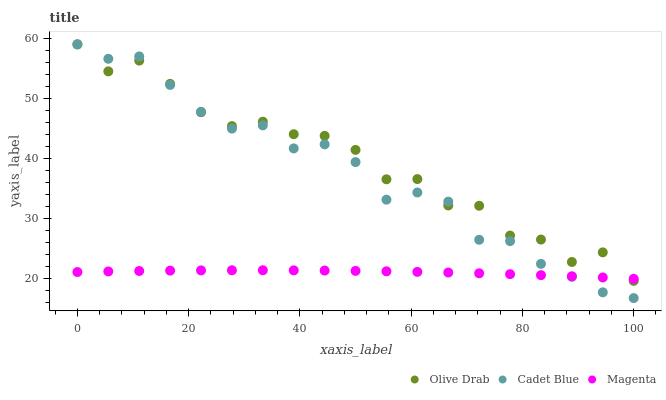Does Magenta have the minimum area under the curve?
Answer yes or no. Yes. Does Olive Drab have the maximum area under the curve?
Answer yes or no. Yes. Does Cadet Blue have the minimum area under the curve?
Answer yes or no. No. Does Cadet Blue have the maximum area under the curve?
Answer yes or no. No. Is Magenta the smoothest?
Answer yes or no. Yes. Is Olive Drab the roughest?
Answer yes or no. Yes. Is Cadet Blue the smoothest?
Answer yes or no. No. Is Cadet Blue the roughest?
Answer yes or no. No. Does Cadet Blue have the lowest value?
Answer yes or no. Yes. Does Olive Drab have the lowest value?
Answer yes or no. No. Does Olive Drab have the highest value?
Answer yes or no. Yes. Does Cadet Blue have the highest value?
Answer yes or no. No. Does Magenta intersect Cadet Blue?
Answer yes or no. Yes. Is Magenta less than Cadet Blue?
Answer yes or no. No. Is Magenta greater than Cadet Blue?
Answer yes or no. No. 